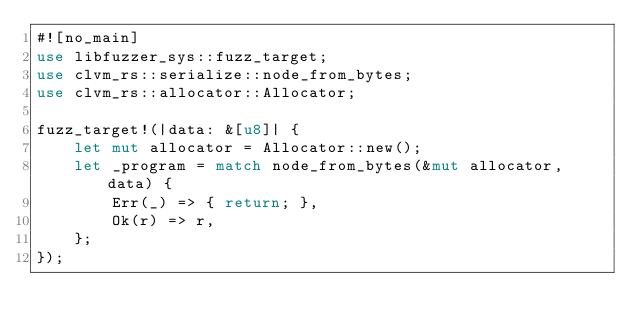Convert code to text. <code><loc_0><loc_0><loc_500><loc_500><_Rust_>#![no_main]
use libfuzzer_sys::fuzz_target;
use clvm_rs::serialize::node_from_bytes;
use clvm_rs::allocator::Allocator;

fuzz_target!(|data: &[u8]| {
    let mut allocator = Allocator::new();
    let _program = match node_from_bytes(&mut allocator, data) {
        Err(_) => { return; },
        Ok(r) => r,
    };
});
</code> 